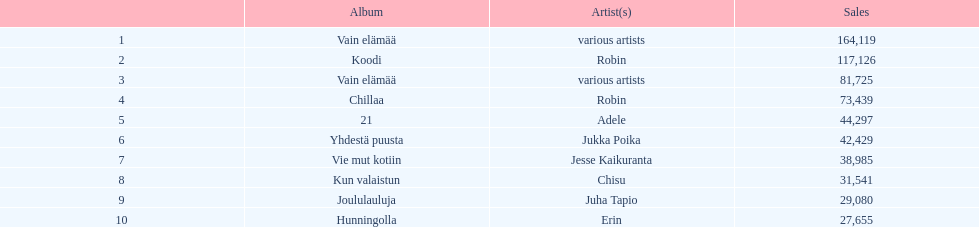Which sold better, hunningolla or vain elamaa? Vain elämää. 